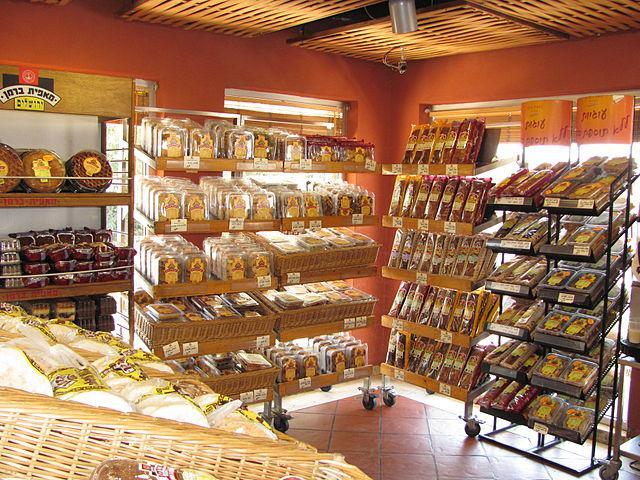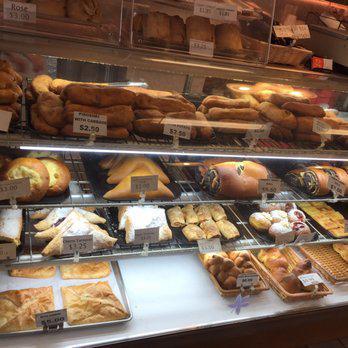The first image is the image on the left, the second image is the image on the right. For the images shown, is this caption "Windows can be seen in the image on the left." true? Answer yes or no. Yes. 